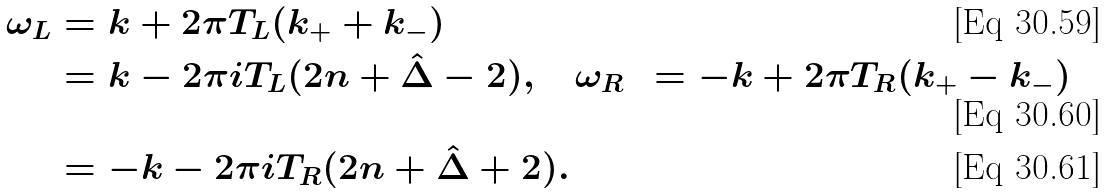<formula> <loc_0><loc_0><loc_500><loc_500>\omega _ { L } & = k + 2 \pi T _ { L } ( k _ { + } + k _ { - } ) \\ & = k - 2 \pi i T _ { L } ( 2 n + \hat { \Delta } - 2 ) , \quad \omega _ { R } & = - k + 2 \pi T _ { R } ( k _ { + } - k _ { - } ) \\ & = - k - 2 \pi i T _ { R } ( 2 n + \hat { \Delta } + 2 ) .</formula> 